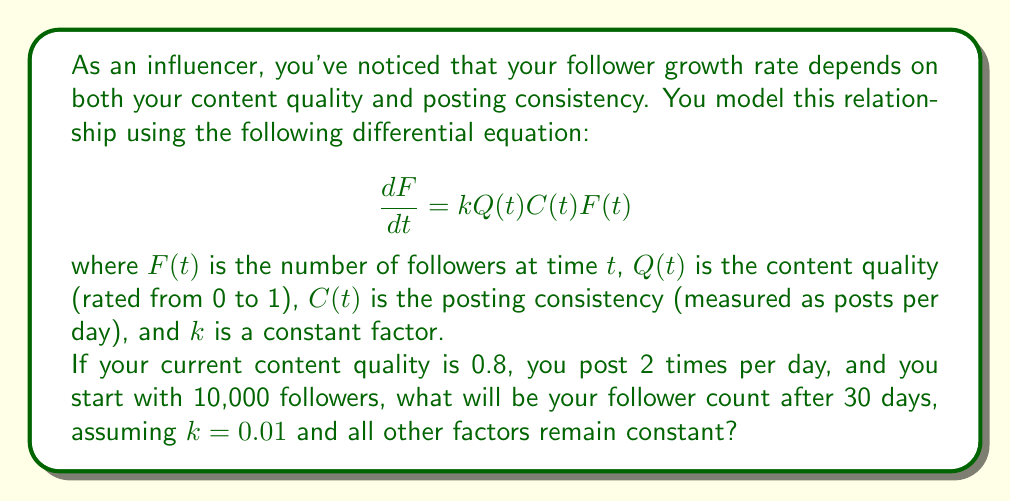What is the answer to this math problem? To solve this problem, we need to integrate the given differential equation. Since $Q(t)$, $C(t)$, and $k$ are constant in this case, we can simplify the equation:

$$\frac{dF}{dt} = kQCF$$

This is a separable differential equation. We can rewrite it as:

$$\frac{dF}{F} = kQC dt$$

Integrating both sides:

$$\int_{F_0}^F \frac{dF}{F} = \int_0^t kQC dt$$

$$\ln(F) - \ln(F_0) = kQCt$$

$$\ln(\frac{F}{F_0}) = kQCt$$

Taking the exponential of both sides:

$$\frac{F}{F_0} = e^{kQCt}$$

$$F = F_0 e^{kQCt}$$

Now, we can plug in the given values:
- $F_0 = 10,000$ (initial followers)
- $k = 0.01$
- $Q = 0.8$ (content quality)
- $C = 2$ (posts per day)
- $t = 30$ (days)

$$F = 10,000 \cdot e^{0.01 \cdot 0.8 \cdot 2 \cdot 30}$$

$$F = 10,000 \cdot e^{0.48}$$

$$F = 10,000 \cdot 1.6161...$$

$$F \approx 16,161$$
Answer: After 30 days, the influencer will have approximately 16,161 followers. 